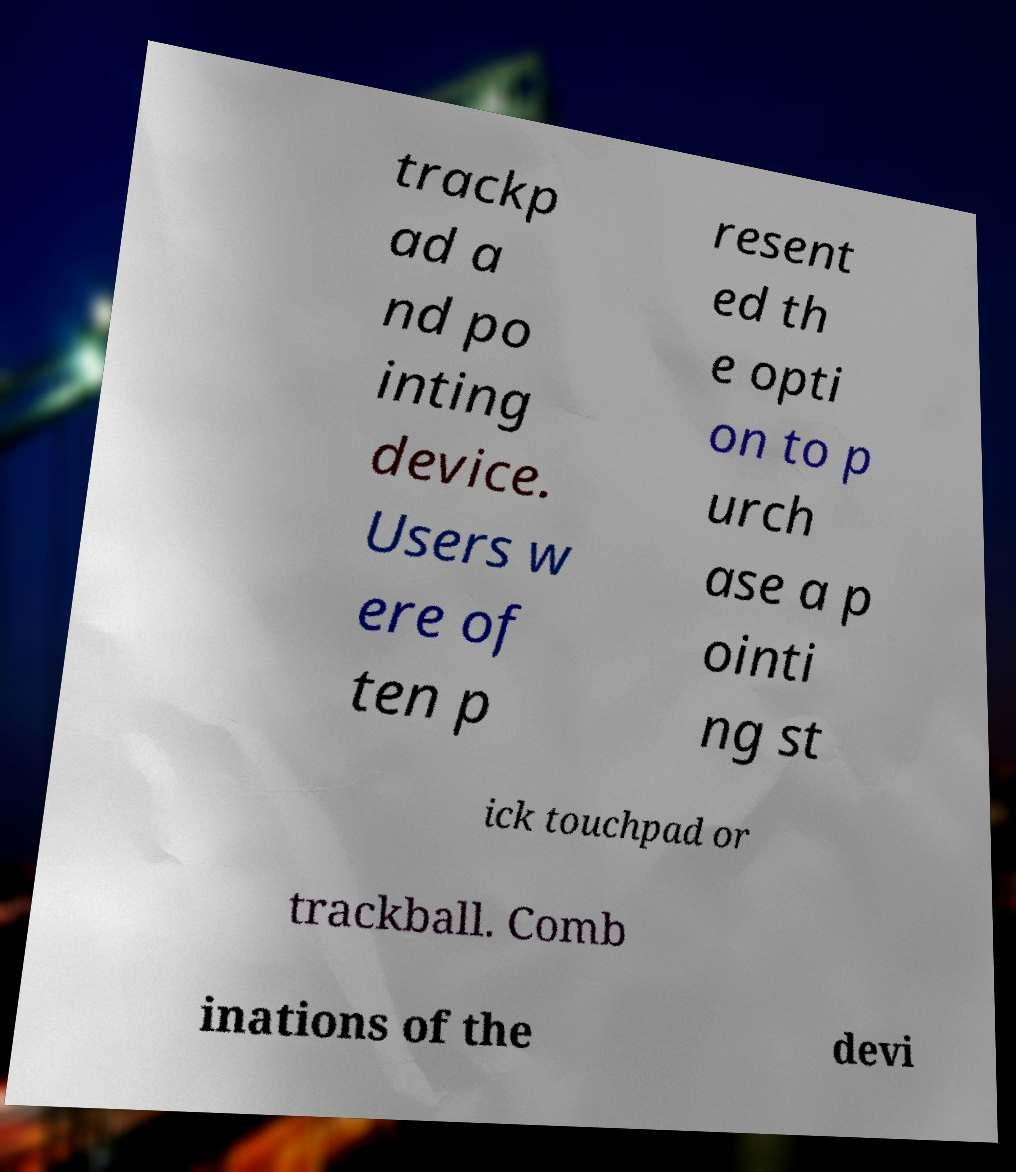Please read and relay the text visible in this image. What does it say? trackp ad a nd po inting device. Users w ere of ten p resent ed th e opti on to p urch ase a p ointi ng st ick touchpad or trackball. Comb inations of the devi 